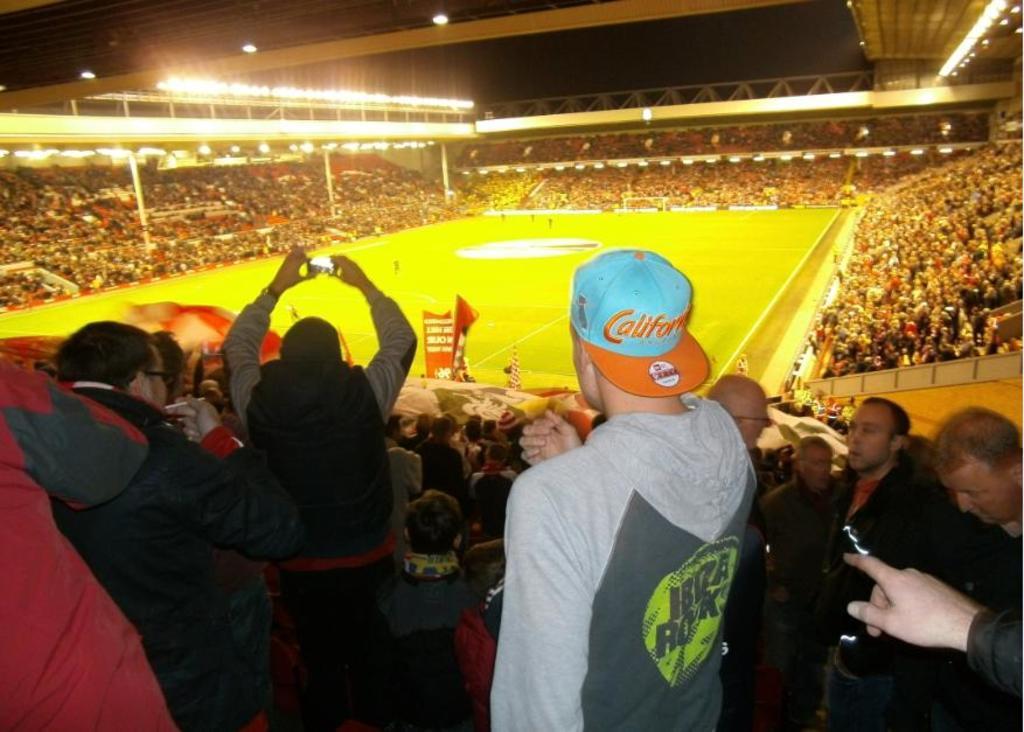Can you describe this image briefly? This is a picture of a stadium, where there are group of people standing and sitting, and there are flags , lights , and in the background there is sky. 